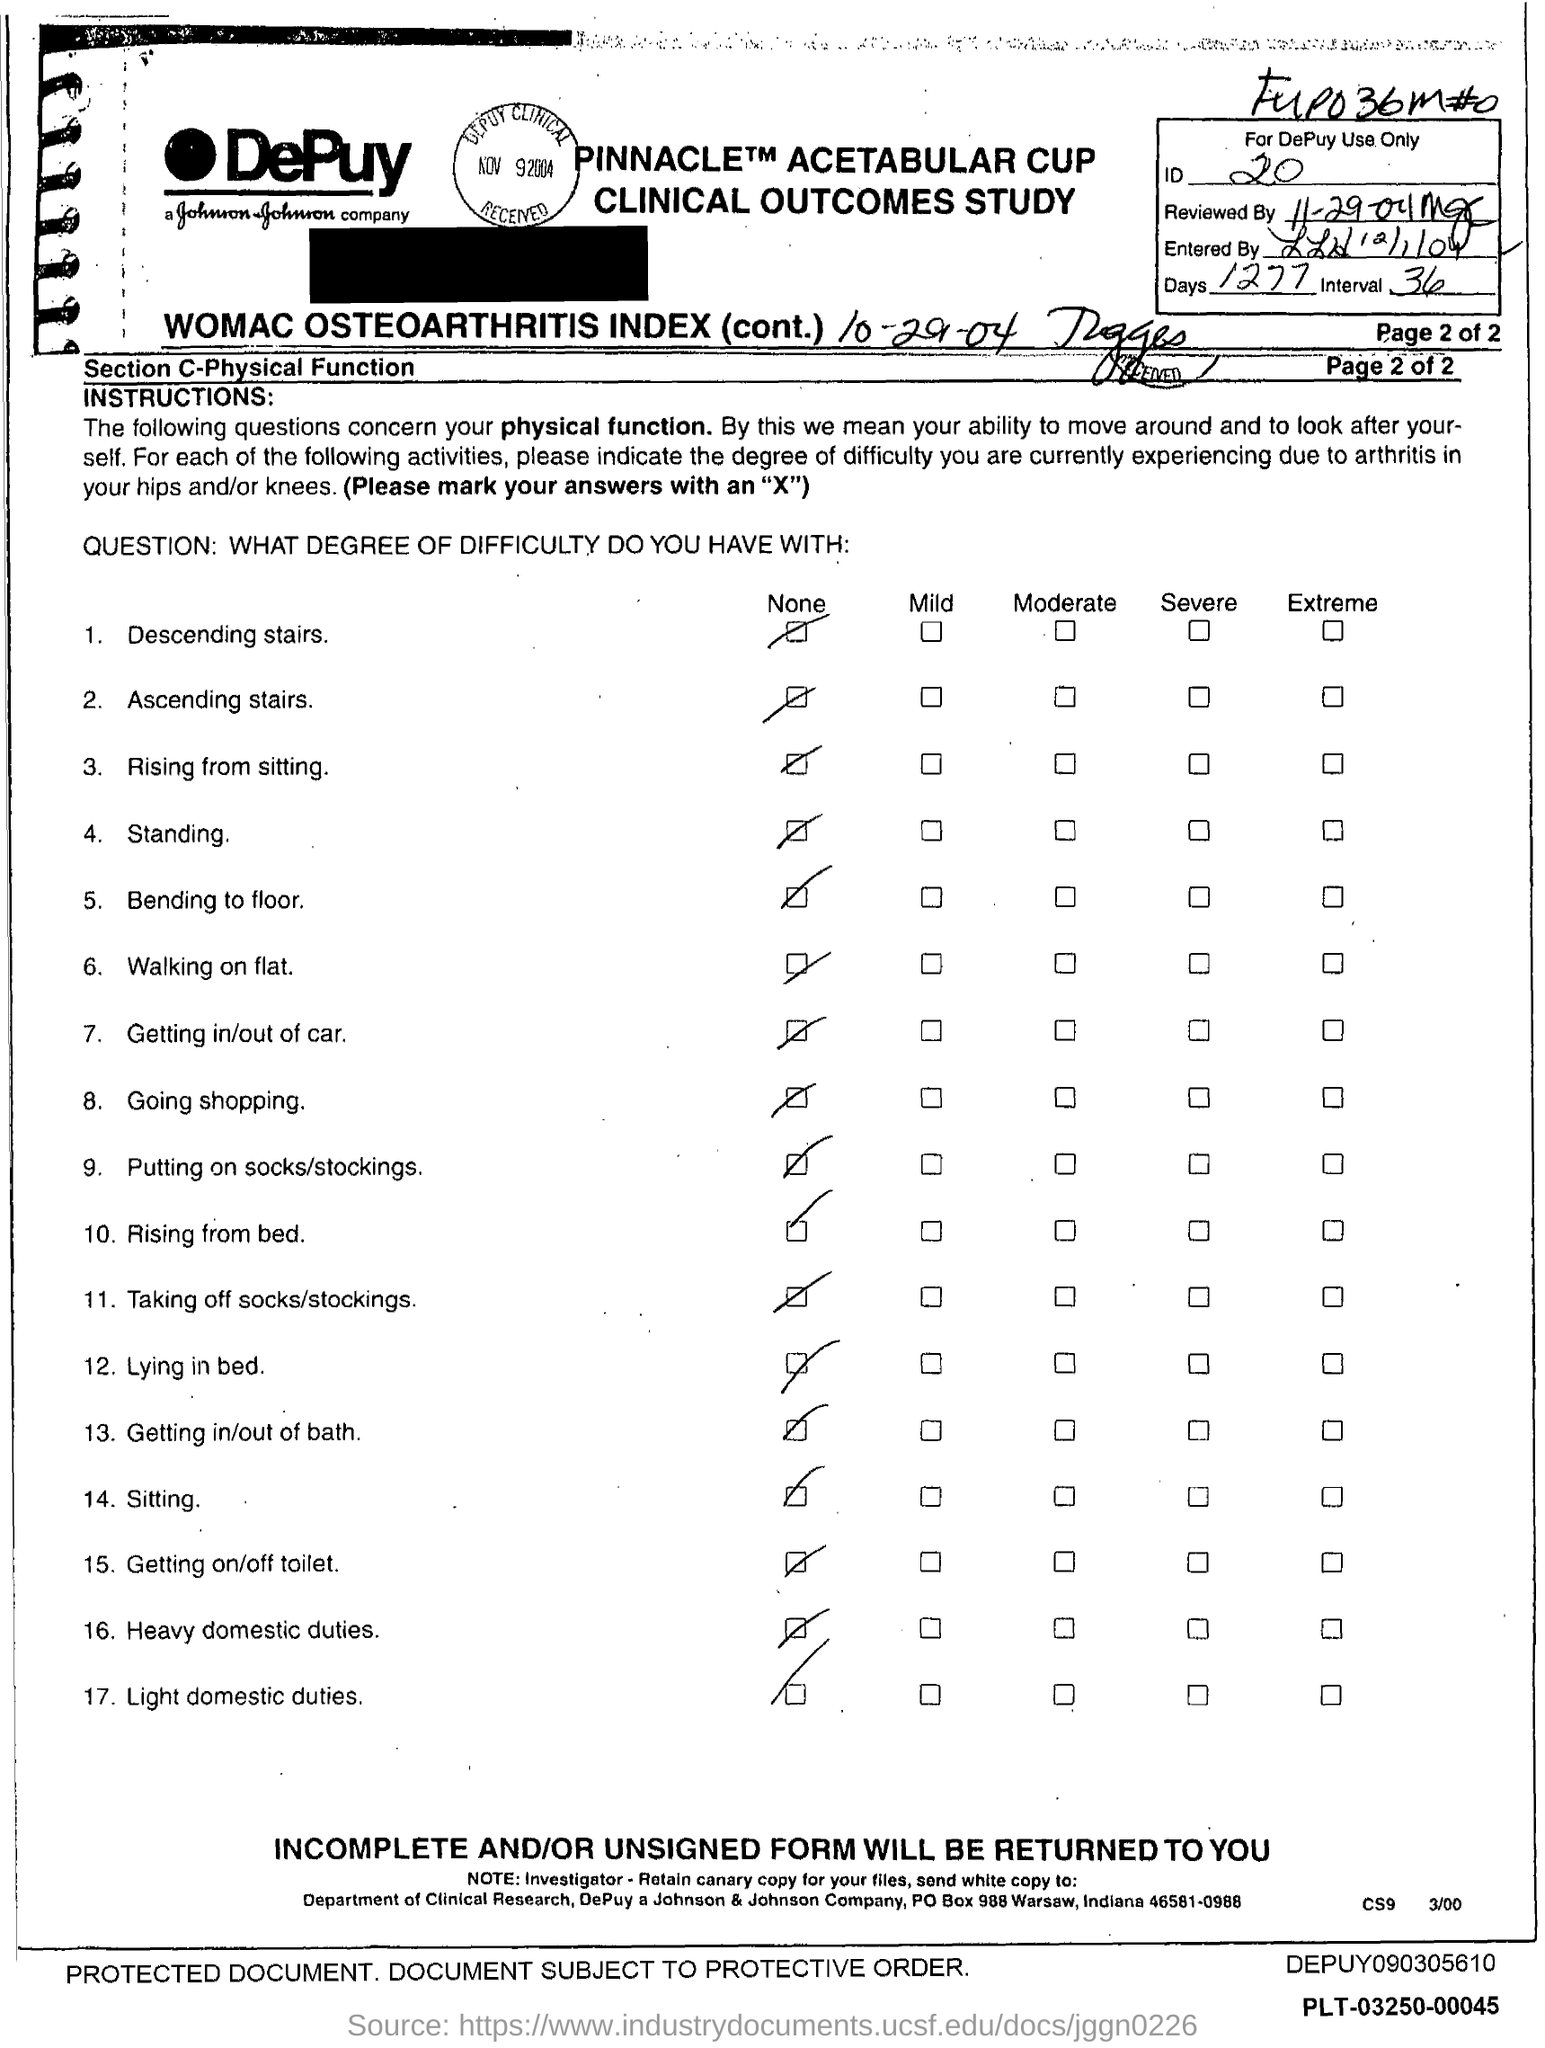Highlight a few significant elements in this photo. The ID Number is 20... There are 1277 days. 